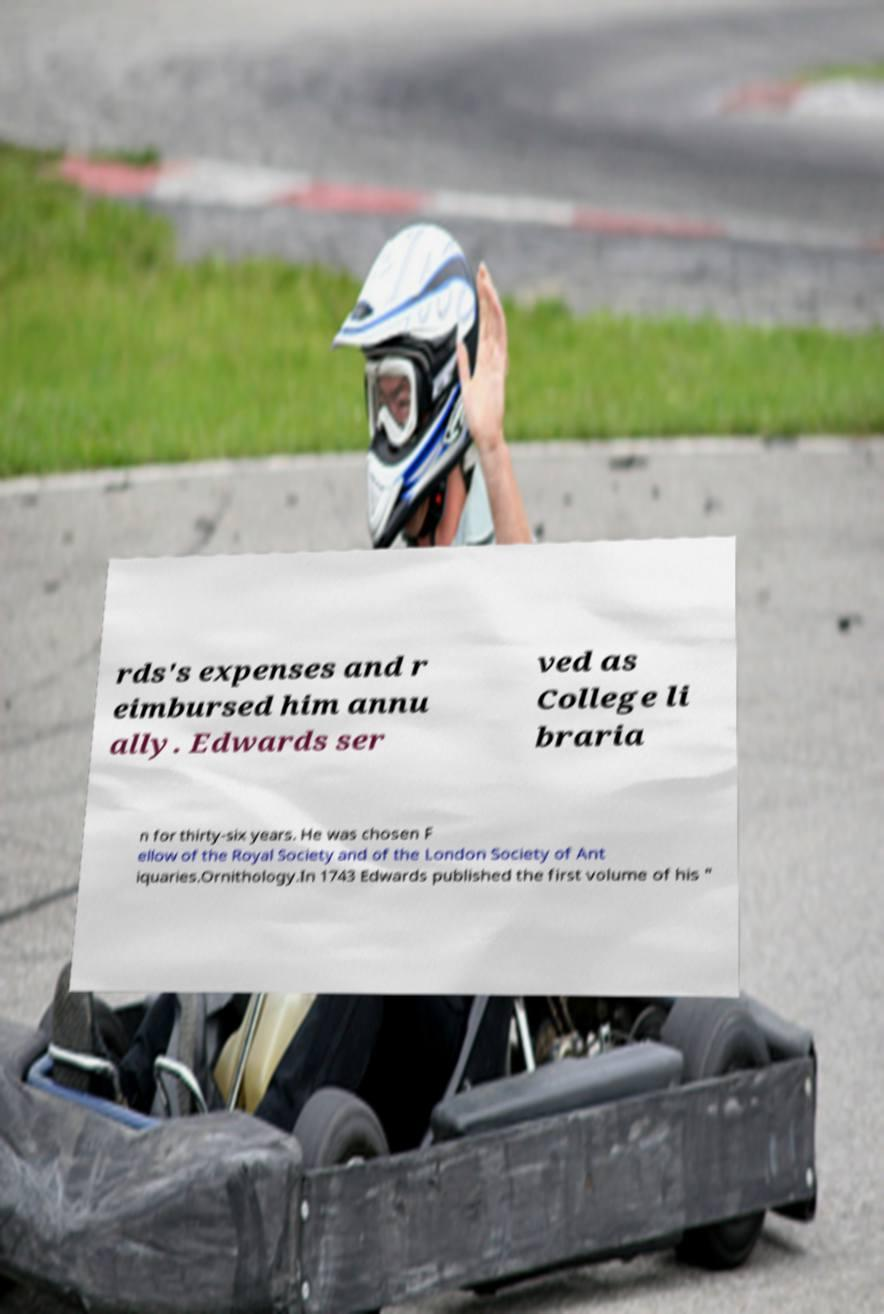There's text embedded in this image that I need extracted. Can you transcribe it verbatim? rds's expenses and r eimbursed him annu ally. Edwards ser ved as College li braria n for thirty-six years. He was chosen F ellow of the Royal Society and of the London Society of Ant iquaries.Ornithology.In 1743 Edwards published the first volume of his " 